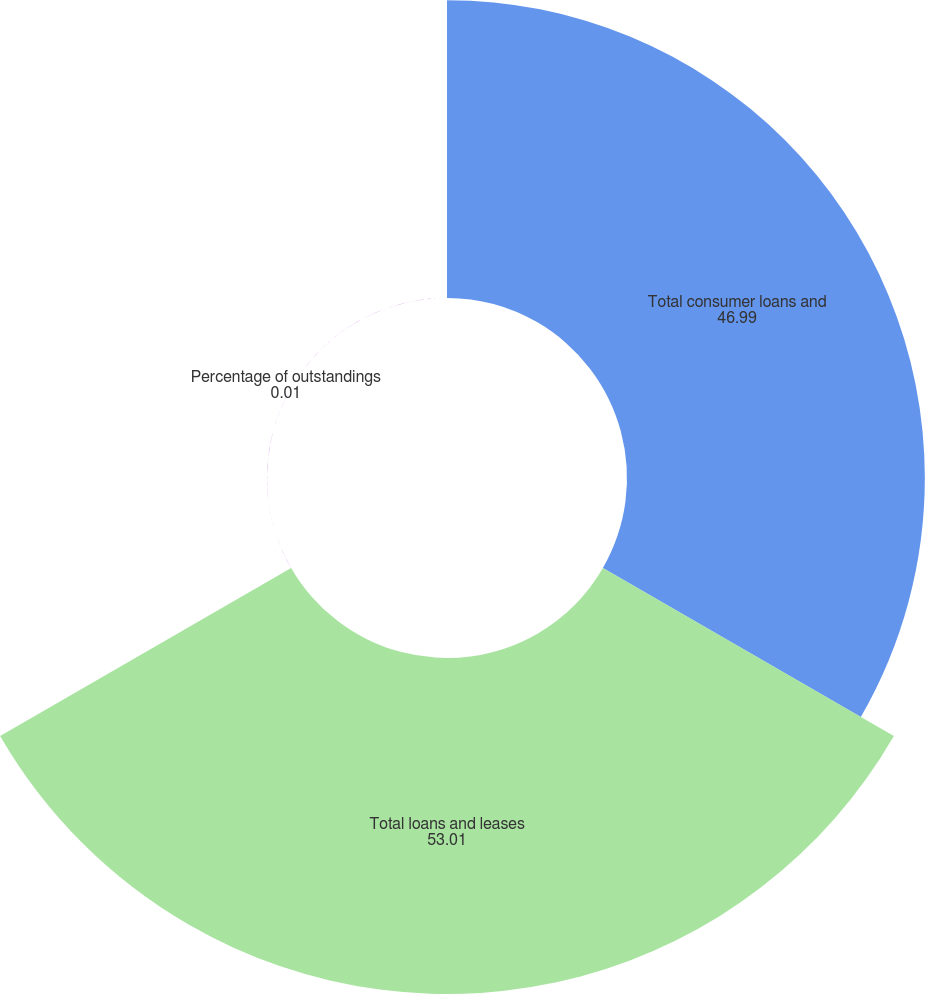Convert chart to OTSL. <chart><loc_0><loc_0><loc_500><loc_500><pie_chart><fcel>Total consumer loans and<fcel>Total loans and leases<fcel>Percentage of outstandings<nl><fcel>46.99%<fcel>53.01%<fcel>0.01%<nl></chart> 